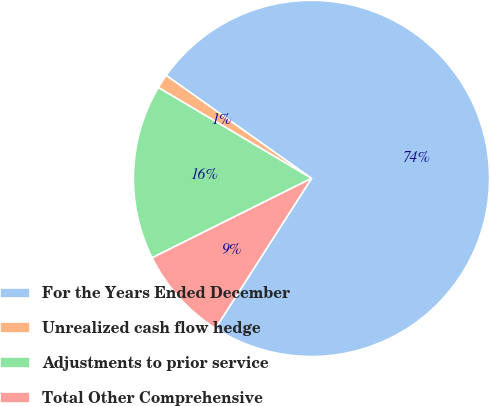Convert chart to OTSL. <chart><loc_0><loc_0><loc_500><loc_500><pie_chart><fcel>For the Years Ended December<fcel>Unrealized cash flow hedge<fcel>Adjustments to prior service<fcel>Total Other Comprehensive<nl><fcel>74.25%<fcel>1.29%<fcel>15.88%<fcel>8.58%<nl></chart> 